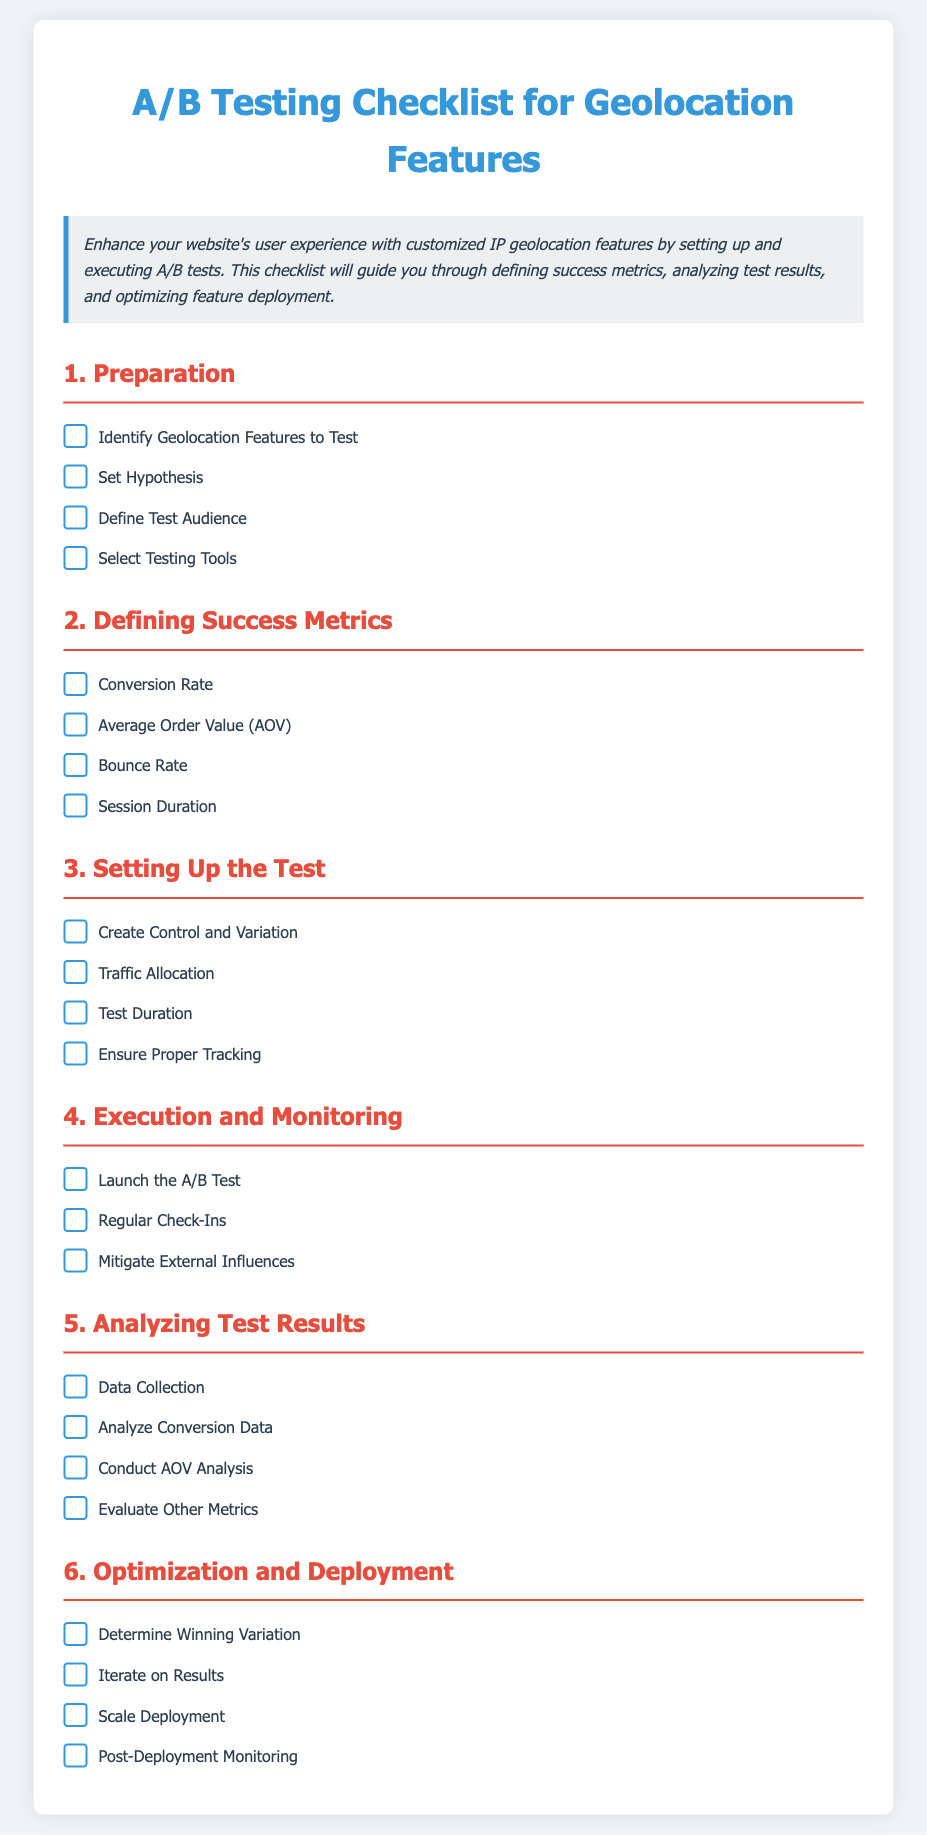What is the main purpose of the checklist? The checklist guides users through setting up and executing A/B tests for geolocation features on their site.
Answer: A/B testing guidance How many main sections are in the checklist? The checklist contains six main sections outlined for conducting A/B tests.
Answer: Six What is one of the success metrics listed for the A/B tests? The checklist includes multiple success metrics, one of which is the conversion rate.
Answer: Conversion Rate What should be created to set up the test? The checklist specifies that a control and variation should be created during the setup of the test.
Answer: Control and Variation In which section is "Post-Deployment Monitoring" mentioned? "Post-Deployment Monitoring" is mentioned in the sixth section, which focuses on Optimization and Deployment.
Answer: Optimization and Deployment What is required for the execution phase of the A/B test? The execution phase requires launching the A/B test as stated in the corresponding section.
Answer: Launch the A/B Test How often should check-ins occur during the test? The checklist suggests regular check-ins during the execution and monitoring phase.
Answer: Regular Check-Ins What does AOV stand for in the context of analyzing test results? AOV stands for Average Order Value, a metric analyzed during test result analysis.
Answer: Average Order Value What is the last step mentioned in the optimization and deployment section? The last step mentioned is "Post-Deployment Monitoring."
Answer: Post-Deployment Monitoring 